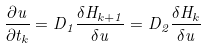<formula> <loc_0><loc_0><loc_500><loc_500>\frac { \partial u } { \partial t _ { k } } = D _ { 1 } \frac { \delta H _ { k + 1 } } { \delta u } = D _ { 2 } \frac { \delta H _ { k } } { \delta u }</formula> 